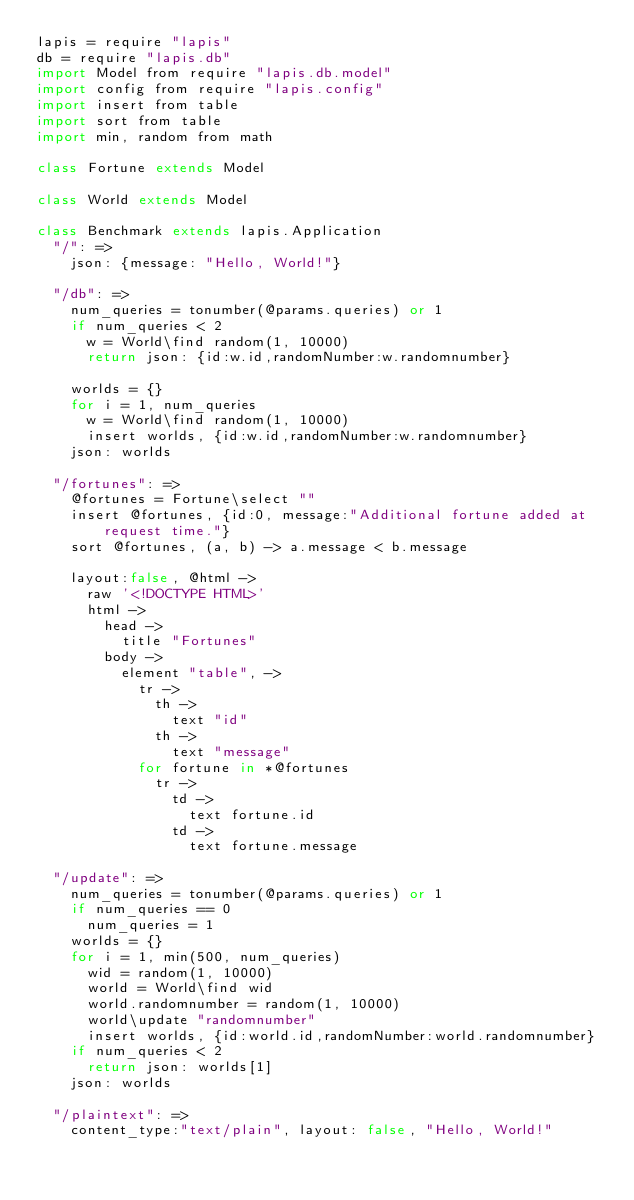<code> <loc_0><loc_0><loc_500><loc_500><_MoonScript_>lapis = require "lapis"
db = require "lapis.db"
import Model from require "lapis.db.model"
import config from require "lapis.config"
import insert from table
import sort from table
import min, random from math

class Fortune extends Model

class World extends Model

class Benchmark extends lapis.Application
  "/": =>
    json: {message: "Hello, World!"}

  "/db": =>
    num_queries = tonumber(@params.queries) or 1
    if num_queries < 2 
      w = World\find random(1, 10000)
      return json: {id:w.id,randomNumber:w.randomnumber}

    worlds = {}
    for i = 1, num_queries
      w = World\find random(1, 10000)
      insert worlds, {id:w.id,randomNumber:w.randomnumber} 
    json: worlds

  "/fortunes": =>
    @fortunes = Fortune\select ""
    insert @fortunes, {id:0, message:"Additional fortune added at request time."}
    sort @fortunes, (a, b) -> a.message < b.message

    layout:false, @html ->
      raw '<!DOCTYPE HTML>'
      html ->
        head ->
          title "Fortunes"
        body ->
          element "table", ->
            tr ->
              th ->
                text "id"
              th ->
                text "message"
            for fortune in *@fortunes
              tr ->
                td ->
                  text fortune.id
                td ->
                  text fortune.message

  "/update": =>
    num_queries = tonumber(@params.queries) or 1
    if num_queries == 0
      num_queries = 1
    worlds = {}
    for i = 1, min(500, num_queries)
      wid = random(1, 10000)
      world = World\find wid
      world.randomnumber = random(1, 10000)
      world\update "randomnumber"
      insert worlds, {id:world.id,randomNumber:world.randomnumber} 
    if num_queries < 2
      return json: worlds[1]
    json: worlds

  "/plaintext": =>
    content_type:"text/plain", layout: false, "Hello, World!"
              
</code> 